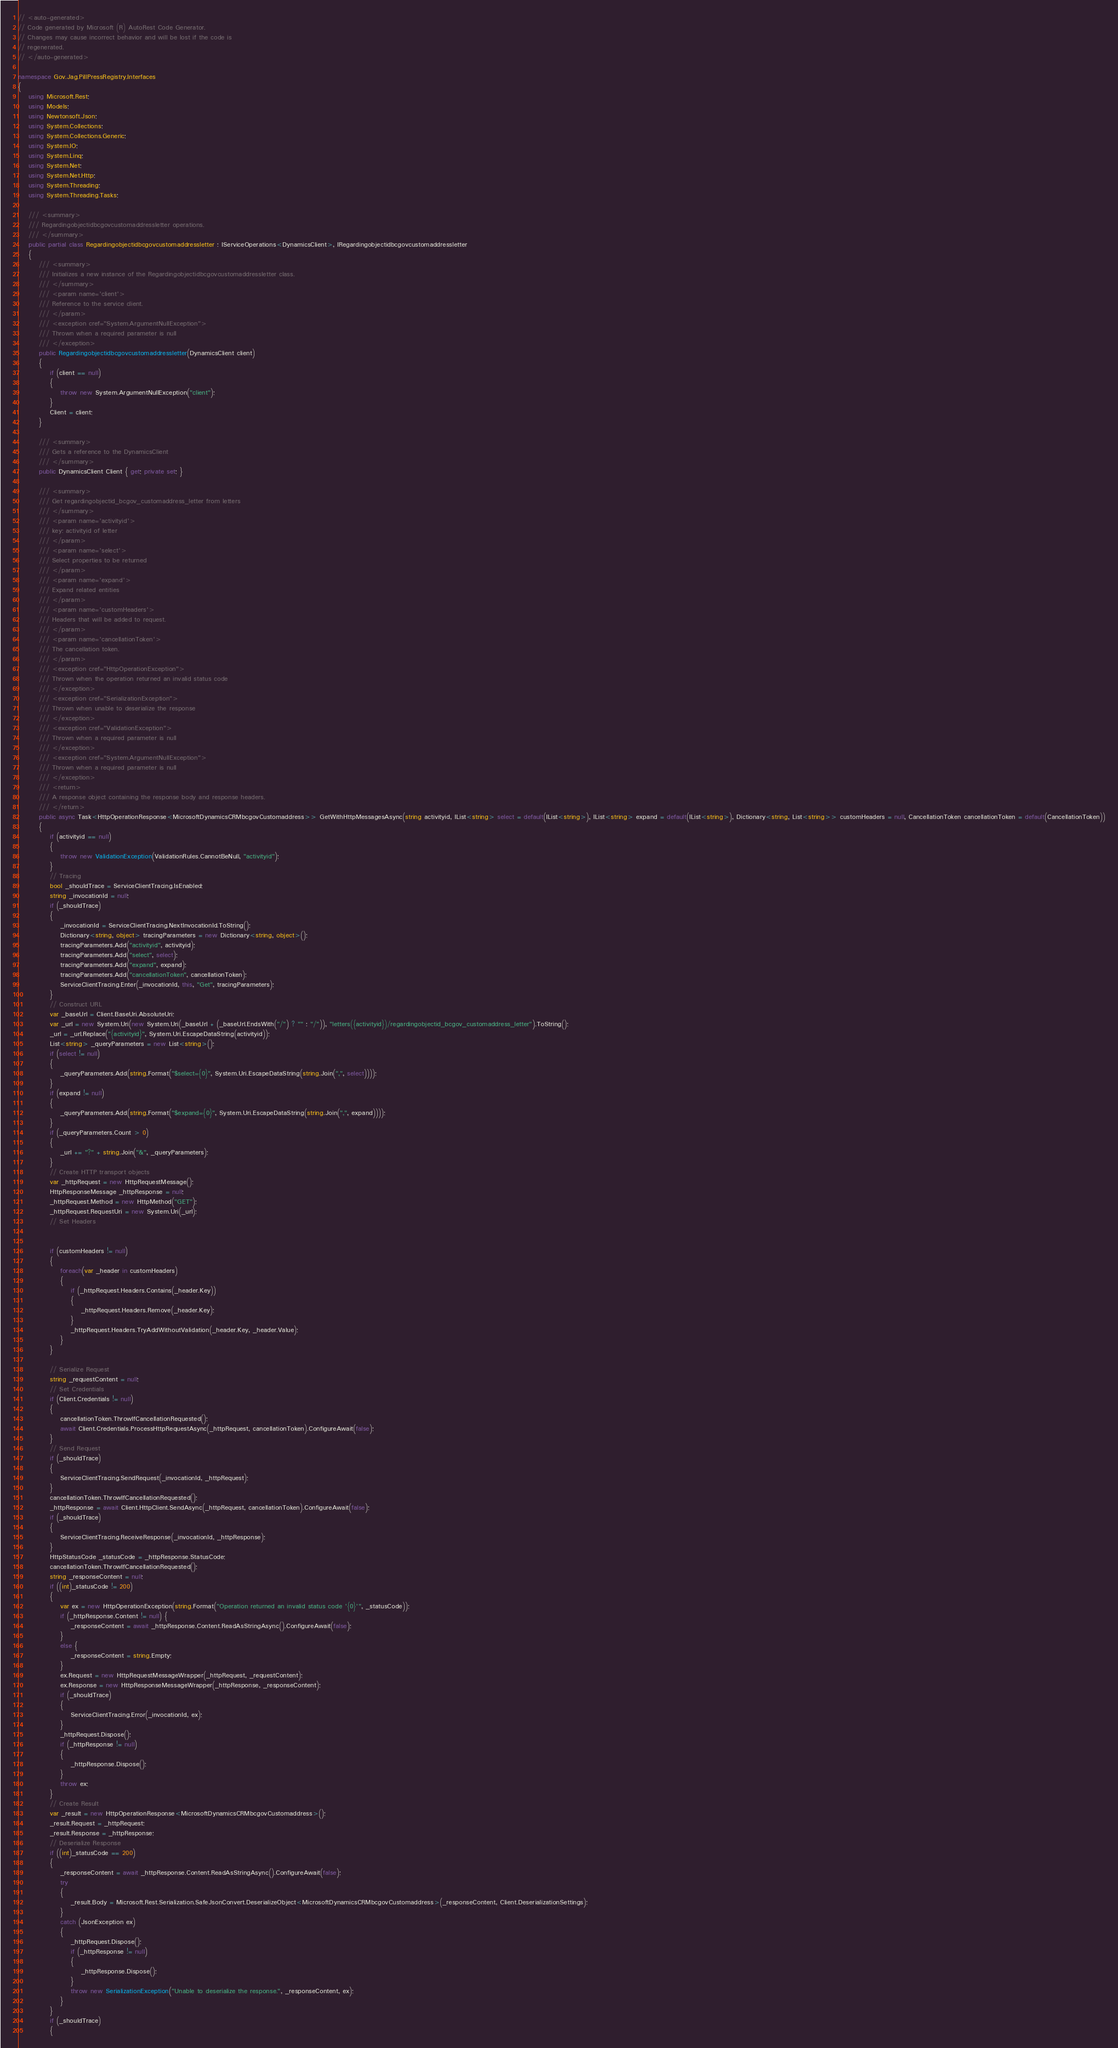Convert code to text. <code><loc_0><loc_0><loc_500><loc_500><_C#_>// <auto-generated>
// Code generated by Microsoft (R) AutoRest Code Generator.
// Changes may cause incorrect behavior and will be lost if the code is
// regenerated.
// </auto-generated>

namespace Gov.Jag.PillPressRegistry.Interfaces
{
    using Microsoft.Rest;
    using Models;
    using Newtonsoft.Json;
    using System.Collections;
    using System.Collections.Generic;
    using System.IO;
    using System.Linq;
    using System.Net;
    using System.Net.Http;
    using System.Threading;
    using System.Threading.Tasks;

    /// <summary>
    /// Regardingobjectidbcgovcustomaddressletter operations.
    /// </summary>
    public partial class Regardingobjectidbcgovcustomaddressletter : IServiceOperations<DynamicsClient>, IRegardingobjectidbcgovcustomaddressletter
    {
        /// <summary>
        /// Initializes a new instance of the Regardingobjectidbcgovcustomaddressletter class.
        /// </summary>
        /// <param name='client'>
        /// Reference to the service client.
        /// </param>
        /// <exception cref="System.ArgumentNullException">
        /// Thrown when a required parameter is null
        /// </exception>
        public Regardingobjectidbcgovcustomaddressletter(DynamicsClient client)
        {
            if (client == null)
            {
                throw new System.ArgumentNullException("client");
            }
            Client = client;
        }

        /// <summary>
        /// Gets a reference to the DynamicsClient
        /// </summary>
        public DynamicsClient Client { get; private set; }

        /// <summary>
        /// Get regardingobjectid_bcgov_customaddress_letter from letters
        /// </summary>
        /// <param name='activityid'>
        /// key: activityid of letter
        /// </param>
        /// <param name='select'>
        /// Select properties to be returned
        /// </param>
        /// <param name='expand'>
        /// Expand related entities
        /// </param>
        /// <param name='customHeaders'>
        /// Headers that will be added to request.
        /// </param>
        /// <param name='cancellationToken'>
        /// The cancellation token.
        /// </param>
        /// <exception cref="HttpOperationException">
        /// Thrown when the operation returned an invalid status code
        /// </exception>
        /// <exception cref="SerializationException">
        /// Thrown when unable to deserialize the response
        /// </exception>
        /// <exception cref="ValidationException">
        /// Thrown when a required parameter is null
        /// </exception>
        /// <exception cref="System.ArgumentNullException">
        /// Thrown when a required parameter is null
        /// </exception>
        /// <return>
        /// A response object containing the response body and response headers.
        /// </return>
        public async Task<HttpOperationResponse<MicrosoftDynamicsCRMbcgovCustomaddress>> GetWithHttpMessagesAsync(string activityid, IList<string> select = default(IList<string>), IList<string> expand = default(IList<string>), Dictionary<string, List<string>> customHeaders = null, CancellationToken cancellationToken = default(CancellationToken))
        {
            if (activityid == null)
            {
                throw new ValidationException(ValidationRules.CannotBeNull, "activityid");
            }
            // Tracing
            bool _shouldTrace = ServiceClientTracing.IsEnabled;
            string _invocationId = null;
            if (_shouldTrace)
            {
                _invocationId = ServiceClientTracing.NextInvocationId.ToString();
                Dictionary<string, object> tracingParameters = new Dictionary<string, object>();
                tracingParameters.Add("activityid", activityid);
                tracingParameters.Add("select", select);
                tracingParameters.Add("expand", expand);
                tracingParameters.Add("cancellationToken", cancellationToken);
                ServiceClientTracing.Enter(_invocationId, this, "Get", tracingParameters);
            }
            // Construct URL
            var _baseUrl = Client.BaseUri.AbsoluteUri;
            var _url = new System.Uri(new System.Uri(_baseUrl + (_baseUrl.EndsWith("/") ? "" : "/")), "letters({activityid})/regardingobjectid_bcgov_customaddress_letter").ToString();
            _url = _url.Replace("{activityid}", System.Uri.EscapeDataString(activityid));
            List<string> _queryParameters = new List<string>();
            if (select != null)
            {
                _queryParameters.Add(string.Format("$select={0}", System.Uri.EscapeDataString(string.Join(",", select))));
            }
            if (expand != null)
            {
                _queryParameters.Add(string.Format("$expand={0}", System.Uri.EscapeDataString(string.Join(",", expand))));
            }
            if (_queryParameters.Count > 0)
            {
                _url += "?" + string.Join("&", _queryParameters);
            }
            // Create HTTP transport objects
            var _httpRequest = new HttpRequestMessage();
            HttpResponseMessage _httpResponse = null;
            _httpRequest.Method = new HttpMethod("GET");
            _httpRequest.RequestUri = new System.Uri(_url);
            // Set Headers


            if (customHeaders != null)
            {
                foreach(var _header in customHeaders)
                {
                    if (_httpRequest.Headers.Contains(_header.Key))
                    {
                        _httpRequest.Headers.Remove(_header.Key);
                    }
                    _httpRequest.Headers.TryAddWithoutValidation(_header.Key, _header.Value);
                }
            }

            // Serialize Request
            string _requestContent = null;
            // Set Credentials
            if (Client.Credentials != null)
            {
                cancellationToken.ThrowIfCancellationRequested();
                await Client.Credentials.ProcessHttpRequestAsync(_httpRequest, cancellationToken).ConfigureAwait(false);
            }
            // Send Request
            if (_shouldTrace)
            {
                ServiceClientTracing.SendRequest(_invocationId, _httpRequest);
            }
            cancellationToken.ThrowIfCancellationRequested();
            _httpResponse = await Client.HttpClient.SendAsync(_httpRequest, cancellationToken).ConfigureAwait(false);
            if (_shouldTrace)
            {
                ServiceClientTracing.ReceiveResponse(_invocationId, _httpResponse);
            }
            HttpStatusCode _statusCode = _httpResponse.StatusCode;
            cancellationToken.ThrowIfCancellationRequested();
            string _responseContent = null;
            if ((int)_statusCode != 200)
            {
                var ex = new HttpOperationException(string.Format("Operation returned an invalid status code '{0}'", _statusCode));
                if (_httpResponse.Content != null) {
                    _responseContent = await _httpResponse.Content.ReadAsStringAsync().ConfigureAwait(false);
                }
                else {
                    _responseContent = string.Empty;
                }
                ex.Request = new HttpRequestMessageWrapper(_httpRequest, _requestContent);
                ex.Response = new HttpResponseMessageWrapper(_httpResponse, _responseContent);
                if (_shouldTrace)
                {
                    ServiceClientTracing.Error(_invocationId, ex);
                }
                _httpRequest.Dispose();
                if (_httpResponse != null)
                {
                    _httpResponse.Dispose();
                }
                throw ex;
            }
            // Create Result
            var _result = new HttpOperationResponse<MicrosoftDynamicsCRMbcgovCustomaddress>();
            _result.Request = _httpRequest;
            _result.Response = _httpResponse;
            // Deserialize Response
            if ((int)_statusCode == 200)
            {
                _responseContent = await _httpResponse.Content.ReadAsStringAsync().ConfigureAwait(false);
                try
                {
                    _result.Body = Microsoft.Rest.Serialization.SafeJsonConvert.DeserializeObject<MicrosoftDynamicsCRMbcgovCustomaddress>(_responseContent, Client.DeserializationSettings);
                }
                catch (JsonException ex)
                {
                    _httpRequest.Dispose();
                    if (_httpResponse != null)
                    {
                        _httpResponse.Dispose();
                    }
                    throw new SerializationException("Unable to deserialize the response.", _responseContent, ex);
                }
            }
            if (_shouldTrace)
            {</code> 